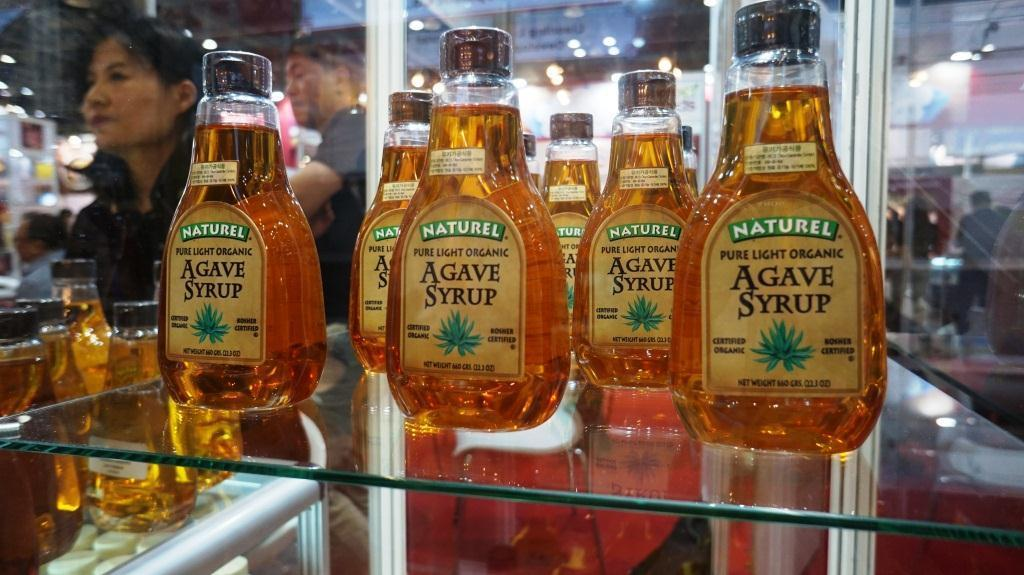<image>
Provide a brief description of the given image. A woman looks at something next to bottles of Agave Syrup. 